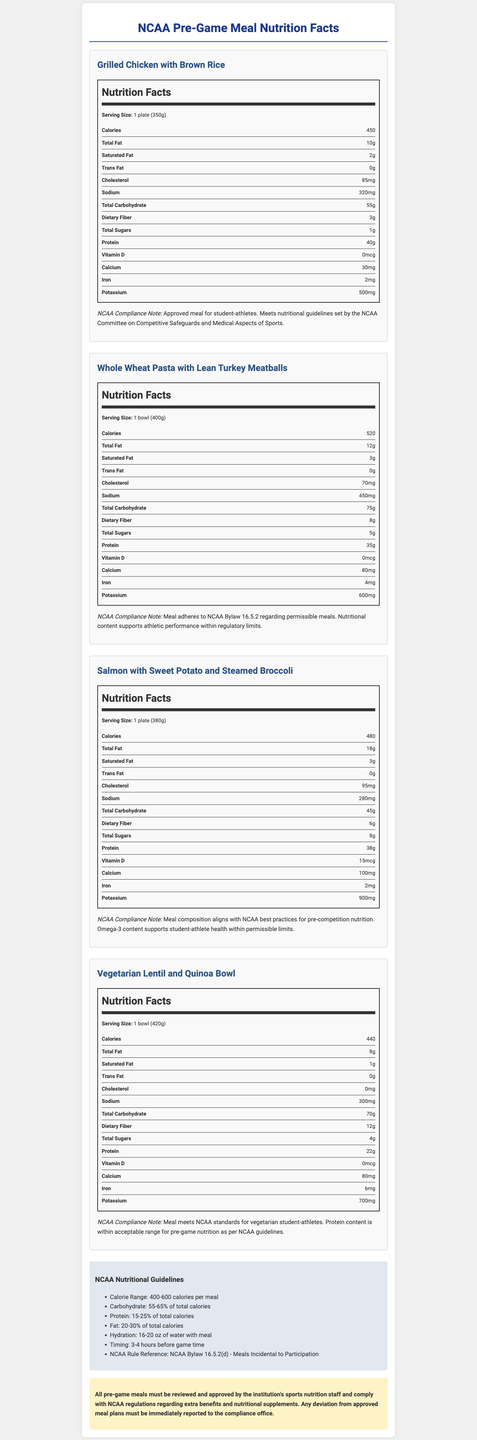what is the serving size of the Grilled Chicken with Brown Rice? The serving size of each meal is listed directly under the meal's name in the document. For "Grilled Chicken with Brown Rice," it is listed as "1 plate (350g)."
Answer: 1 plate (350g) what is the total carbohydrate content in the Whole Wheat Pasta with Lean Turkey Meatballs? The total carbohydrate content is mentioned in the nutritional facts label under "Total Carbohydrate" for each meal. For "Whole Wheat Pasta with Lean Turkey Meatballs," it is 75g.
Answer: 75g what is the sodium content in Salmon with Sweet Potato and Steamed Broccoli? The sodium content for each meal is indicated in the nutrition facts section. For "Salmon with Sweet Potato and Steamed Broccoli," it is 280mg.
Answer: 280mg what is the cholesterol content in the Vegetarian Lentil and Quinoa Bowl? The cholesterol content is listed under "Cholesterol" in the nutritional facts section for each meal. For the "Vegetarian Lentil and Quinoa Bowl," it is 0mg.
Answer: 0mg how much protein is in the Grilled Chicken with Brown Rice meal? The protein content is specified in the nutritional facts section under "Protein." For "Grilled Chicken with Brown Rice," it is 40g.
Answer: 40g which meal has the highest calcium content? A. Grilled Chicken with Brown Rice B. Whole Wheat Pasta with Lean Turkey Meatballs C. Salmon with Sweet Potato and Steamed Broccoli D. Vegetarian Lentil and Quinoa Bowl The calcium content for each meal is shown in the nutrition facts section. The "Salmon with Sweet Potato and Steamed Broccoli" meal has the highest calcium content at 100mg.
Answer: C what is the calorie range recommended by the NCAA for pre-game meals? The recommended calorie range is specified in the "NCAA Nutritional Guidelines" section. It states a range of "400-600 calories per meal."
Answer: 400-600 calories per meal which meal has an adherence note specifically mentioning NCAA Bylaw 16.5.2? A. Grilled Chicken with Brown Rice B. Whole Wheat Pasta with Lean Turkey Meatballs C. Salmon with Sweet Potato and Steamed Broccoli D. Vegetarian Lentil and Quinoa Bowl The "Whole Wheat Pasta with Lean Turkey Meatballs" has a compliance note that specifically mentions NCAA Bylaw 16.5.2.
Answer: B Is the Vegetarian Lentil and Quinoa Bowl compliant with NCAA guidelines for vegetarian athletes? The compliance note for the "Vegetarian Lentil and Quinoa Bowl" explicitly states that the meal meets NCAA standards for vegetarian student-athletes.
Answer: Yes describe the main purpose of this document. The document aims to guide the preparation and approval of pre-game meals for student-athletes, ensuring that the meals meet specific nutritional standards and comply with NCAA regulations. It does this by listing the detailed nutritional content of several meal options and providing overarching guidelines.
Answer: The document provides detailed nutritional information about various pre-game meal options, alongside their compliance with NCAA guidelines for student-athlete meals. It includes specific nutrition facts for each meal and general NCAA nutritional guidelines. what is the amount of Vitamin D in the Whole Wheat Pasta with Lean Turkey Meatballs? The amount of Vitamin D is listed in the nutrition facts under "Vitamin D." For "Whole Wheat Pasta with Lean Turkey Meatballs," it is stated as 0.
Answer: 0 What is the favorite meal of most student-athletes? The document provides detailed nutritional content and compliance information but does not include subjective information like the favorite meal of most student-athletes.
Answer: Not enough information 